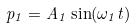Convert formula to latex. <formula><loc_0><loc_0><loc_500><loc_500>p _ { 1 } = A _ { 1 } \sin ( \omega _ { 1 } t )</formula> 